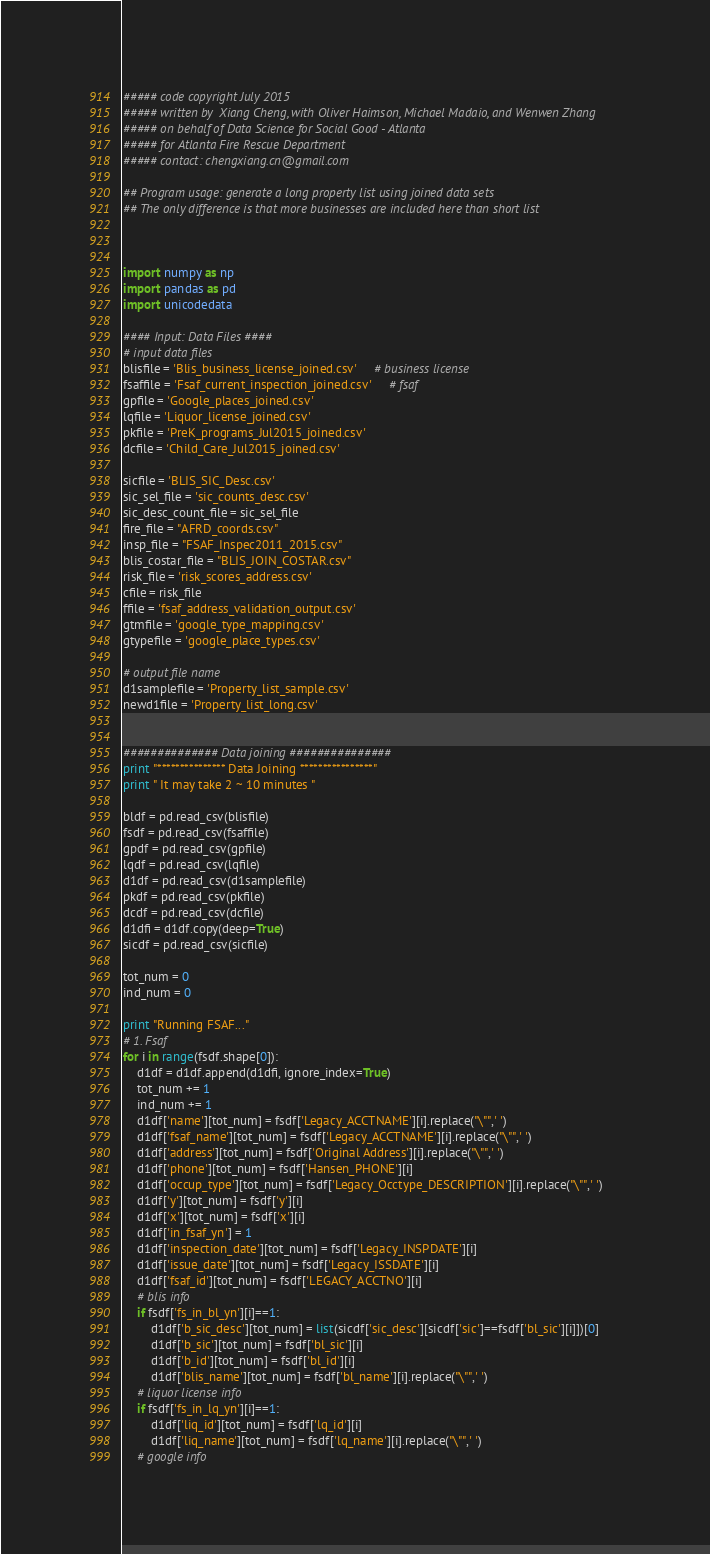<code> <loc_0><loc_0><loc_500><loc_500><_Python_>##### code copyright July 2015 
##### written by  Xiang Cheng, with Oliver Haimson, Michael Madaio, and Wenwen Zhang
##### on behalf of Data Science for Social Good - Atlanta
##### for Atlanta Fire Rescue Department
##### contact: chengxiang.cn@gmail.com

## Program usage: generate a long property list using joined data sets
## The only difference is that more businesses are included here than short list



import numpy as np
import pandas as pd
import unicodedata

#### Input: Data Files ####
# input data files
blisfile = 'Blis_business_license_joined.csv'     # business license
fsaffile = 'Fsaf_current_inspection_joined.csv'     # fsaf
gpfile = 'Google_places_joined.csv'
lqfile = 'Liquor_license_joined.csv'
pkfile = 'PreK_programs_Jul2015_joined.csv'
dcfile = 'Child_Care_Jul2015_joined.csv'

sicfile = 'BLIS_SIC_Desc.csv'
sic_sel_file = 'sic_counts_desc.csv'
sic_desc_count_file = sic_sel_file
fire_file = "AFRD_coords.csv"
insp_file = "FSAF_Inspec2011_2015.csv"
blis_costar_file = "BLIS_JOIN_COSTAR.csv"
risk_file = 'risk_scores_address.csv'
cfile = risk_file
ffile = 'fsaf_address_validation_output.csv'
gtmfile = 'google_type_mapping.csv'
gtypefile = 'google_place_types.csv'

# output file name
d1samplefile = 'Property_list_sample.csv'
newd1file = 'Property_list_long.csv'


############## Data joining ###############
print "*************** Data Joining ****************"
print " It may take 2 ~ 10 minutes "

bldf = pd.read_csv(blisfile)
fsdf = pd.read_csv(fsaffile)
gpdf = pd.read_csv(gpfile)
lqdf = pd.read_csv(lqfile)
d1df = pd.read_csv(d1samplefile) 
pkdf = pd.read_csv(pkfile)
dcdf = pd.read_csv(dcfile)
d1dfi = d1df.copy(deep=True)
sicdf = pd.read_csv(sicfile)

tot_num = 0
ind_num = 0

print "Running FSAF..."
# 1. Fsaf
for i in range(fsdf.shape[0]):
    d1df = d1df.append(d1dfi, ignore_index=True)
    tot_num += 1
    ind_num += 1
    d1df['name'][tot_num] = fsdf['Legacy_ACCTNAME'][i].replace("\"",' ')
    d1df['fsaf_name'][tot_num] = fsdf['Legacy_ACCTNAME'][i].replace("\"",' ')
    d1df['address'][tot_num] = fsdf['Original Address'][i].replace("\"",' ')
    d1df['phone'][tot_num] = fsdf['Hansen_PHONE'][i]
    d1df['occup_type'][tot_num] = fsdf['Legacy_Occtype_DESCRIPTION'][i].replace("\"",' ')
    d1df['y'][tot_num] = fsdf['y'][i]
    d1df['x'][tot_num] = fsdf['x'][i]
    d1df['in_fsaf_yn'] = 1
    d1df['inspection_date'][tot_num] = fsdf['Legacy_INSPDATE'][i]
    d1df['issue_date'][tot_num] = fsdf['Legacy_ISSDATE'][i]
    d1df['fsaf_id'][tot_num] = fsdf['LEGACY_ACCTNO'][i]
    # blis info
    if fsdf['fs_in_bl_yn'][i]==1:
        d1df['b_sic_desc'][tot_num] = list(sicdf['sic_desc'][sicdf['sic']==fsdf['bl_sic'][i]])[0]
        d1df['b_sic'][tot_num] = fsdf['bl_sic'][i]
        d1df['b_id'][tot_num] = fsdf['bl_id'][i]
        d1df['blis_name'][tot_num] = fsdf['bl_name'][i].replace("\"",' ')
    # liquor license info
    if fsdf['fs_in_lq_yn'][i]==1:
        d1df['liq_id'][tot_num] = fsdf['lq_id'][i]
        d1df['liq_name'][tot_num] = fsdf['lq_name'][i].replace("\"",' ')
    # google info</code> 